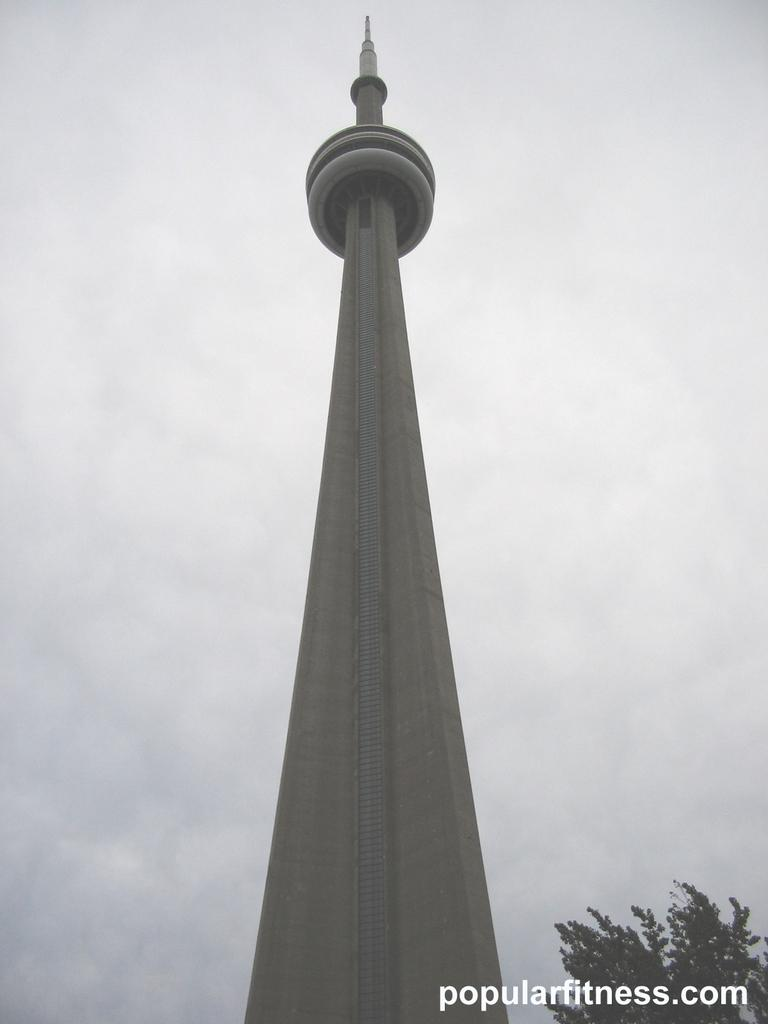What is the main structure in the image? There is a tower in the image. What type of natural elements can be seen in the image? There are trees visible in the image. What is visible in the sky in the image? Clouds are present in the sky in the image. How much wealth is stored in the cellar beneath the tower in the image? There is no mention of a cellar or wealth in the image, so it cannot be determined. 